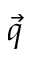Convert formula to latex. <formula><loc_0><loc_0><loc_500><loc_500>\ V e c { q }</formula> 